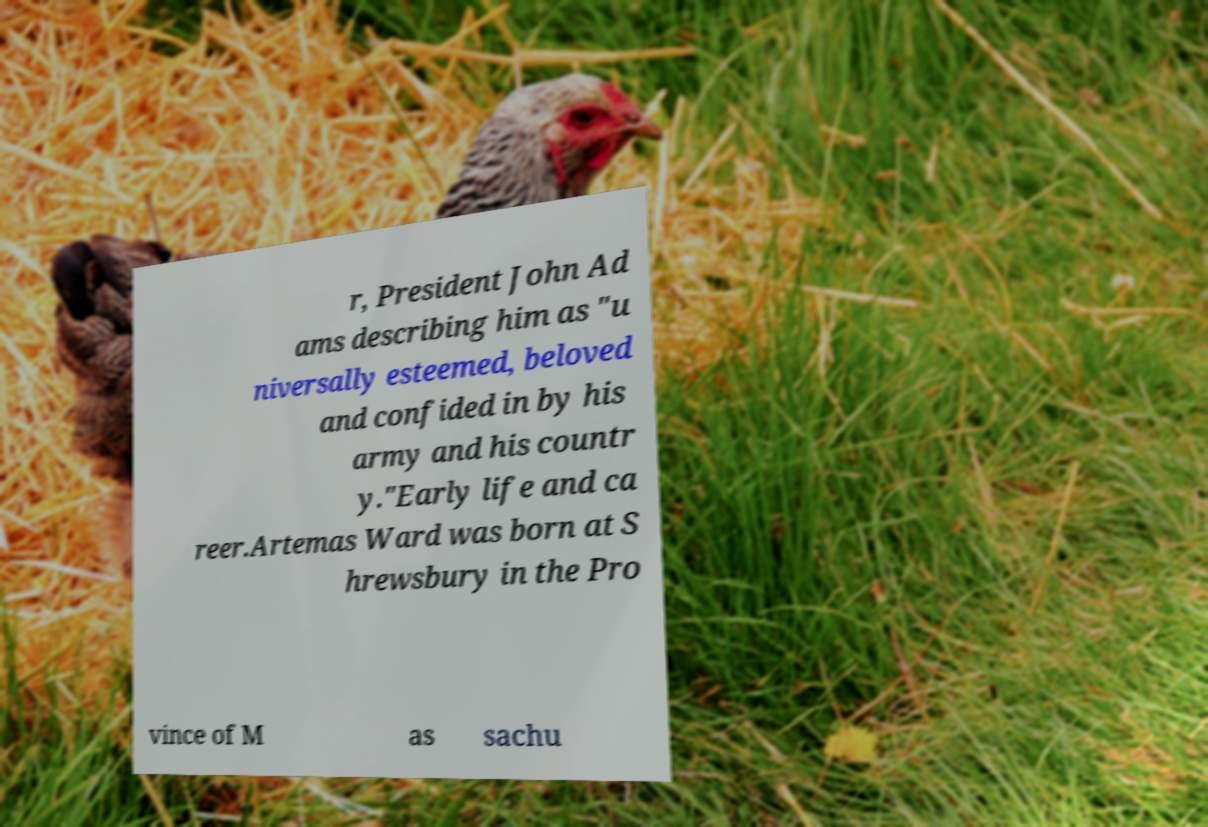Could you assist in decoding the text presented in this image and type it out clearly? r, President John Ad ams describing him as "u niversally esteemed, beloved and confided in by his army and his countr y."Early life and ca reer.Artemas Ward was born at S hrewsbury in the Pro vince of M as sachu 